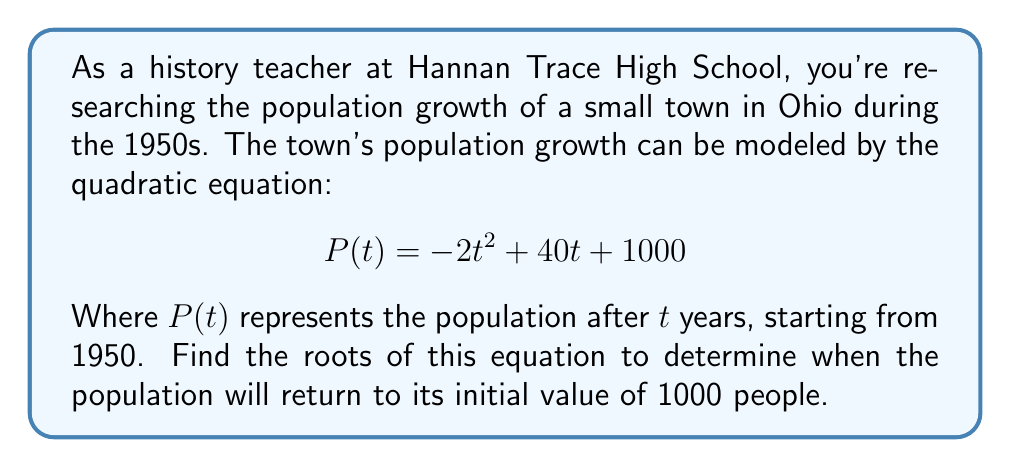Solve this math problem. To find the roots of this quadratic equation, we need to set $P(t) = 1000$ and solve for $t$. This will give us the times when the population equals 1000.

1) Set up the equation:
   $$-2t^2 + 40t + 1000 = 1000$$

2) Simplify by subtracting 1000 from both sides:
   $$-2t^2 + 40t = 0$$

3) Factor out the greatest common factor:
   $$-2t(t - 20) = 0$$

4) Use the zero product property. Either $-2t = 0$ or $(t - 20) = 0$

5) Solve each linear equation:
   From $-2t = 0$, we get $t = 0$
   From $t - 20 = 0$, we get $t = 20$

6) Interpret the results:
   $t = 0$ corresponds to 1950, the starting year.
   $t = 20$ corresponds to 1970, 20 years after the starting point.

The population will return to 1000 people in 1970, 20 years after 1950.
Answer: The roots of the equation are $t = 0$ and $t = 20$, corresponding to the years 1950 and 1970. 